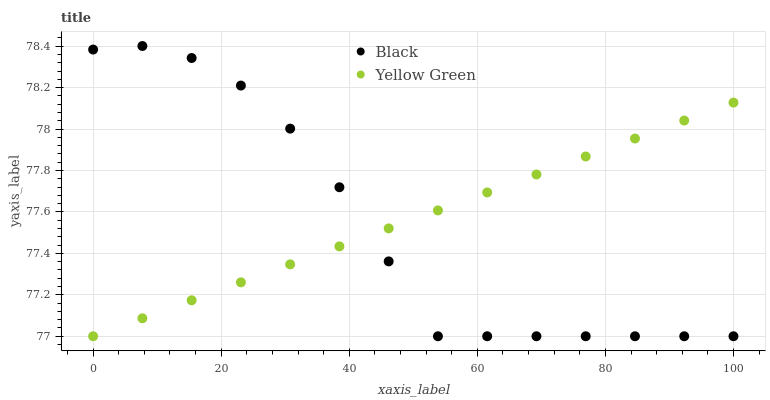Does Black have the minimum area under the curve?
Answer yes or no. Yes. Does Yellow Green have the maximum area under the curve?
Answer yes or no. Yes. Does Yellow Green have the minimum area under the curve?
Answer yes or no. No. Is Yellow Green the smoothest?
Answer yes or no. Yes. Is Black the roughest?
Answer yes or no. Yes. Is Yellow Green the roughest?
Answer yes or no. No. Does Black have the lowest value?
Answer yes or no. Yes. Does Black have the highest value?
Answer yes or no. Yes. Does Yellow Green have the highest value?
Answer yes or no. No. Does Black intersect Yellow Green?
Answer yes or no. Yes. Is Black less than Yellow Green?
Answer yes or no. No. Is Black greater than Yellow Green?
Answer yes or no. No. 